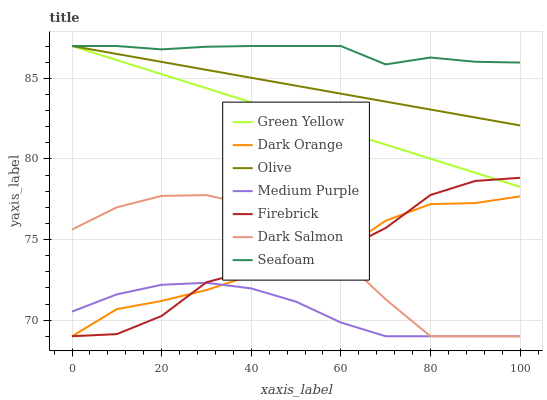Does Medium Purple have the minimum area under the curve?
Answer yes or no. Yes. Does Seafoam have the maximum area under the curve?
Answer yes or no. Yes. Does Firebrick have the minimum area under the curve?
Answer yes or no. No. Does Firebrick have the maximum area under the curve?
Answer yes or no. No. Is Green Yellow the smoothest?
Answer yes or no. Yes. Is Firebrick the roughest?
Answer yes or no. Yes. Is Dark Salmon the smoothest?
Answer yes or no. No. Is Dark Salmon the roughest?
Answer yes or no. No. Does Dark Orange have the lowest value?
Answer yes or no. Yes. Does Seafoam have the lowest value?
Answer yes or no. No. Does Green Yellow have the highest value?
Answer yes or no. Yes. Does Firebrick have the highest value?
Answer yes or no. No. Is Medium Purple less than Green Yellow?
Answer yes or no. Yes. Is Olive greater than Dark Salmon?
Answer yes or no. Yes. Does Olive intersect Green Yellow?
Answer yes or no. Yes. Is Olive less than Green Yellow?
Answer yes or no. No. Is Olive greater than Green Yellow?
Answer yes or no. No. Does Medium Purple intersect Green Yellow?
Answer yes or no. No. 